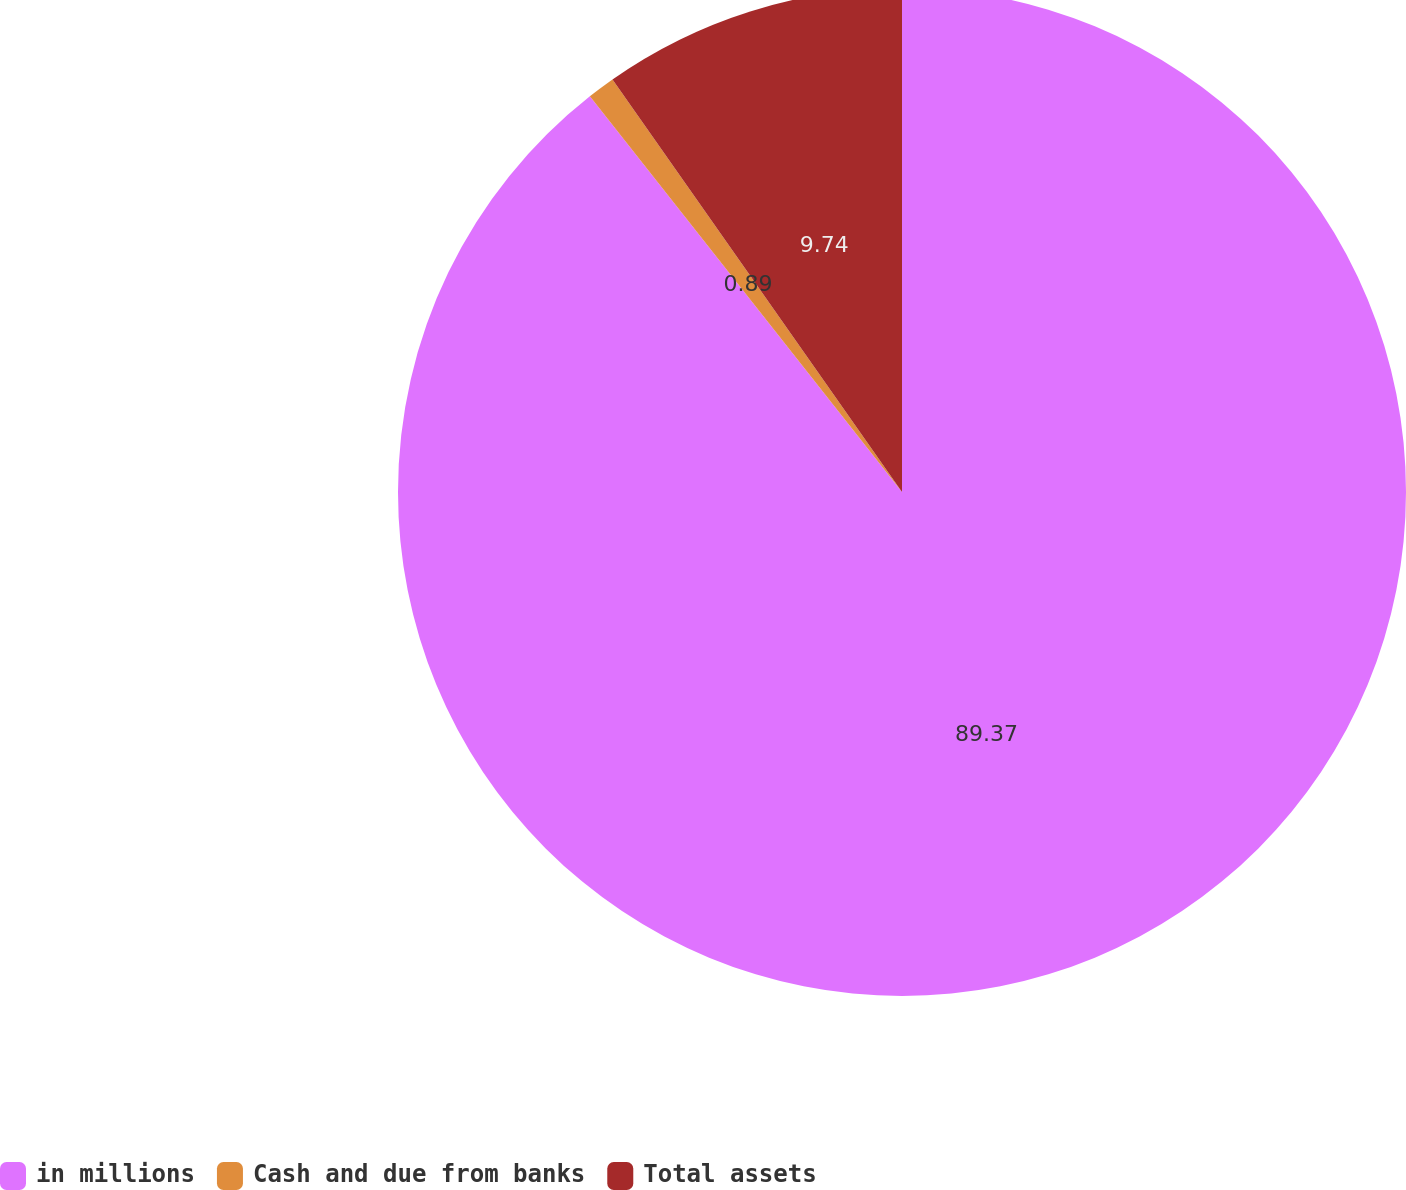Convert chart to OTSL. <chart><loc_0><loc_0><loc_500><loc_500><pie_chart><fcel>in millions<fcel>Cash and due from banks<fcel>Total assets<nl><fcel>89.38%<fcel>0.89%<fcel>9.74%<nl></chart> 